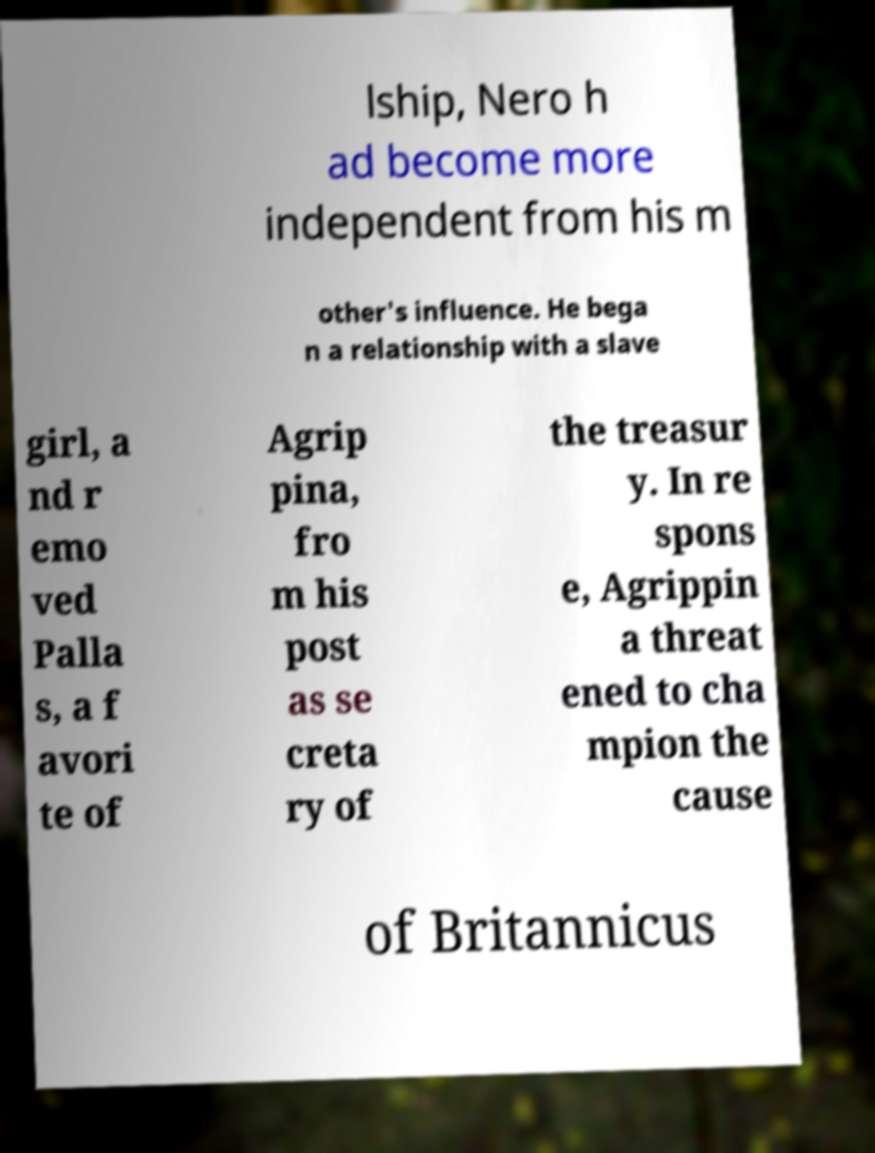Could you assist in decoding the text presented in this image and type it out clearly? lship, Nero h ad become more independent from his m other's influence. He bega n a relationship with a slave girl, a nd r emo ved Palla s, a f avori te of Agrip pina, fro m his post as se creta ry of the treasur y. In re spons e, Agrippin a threat ened to cha mpion the cause of Britannicus 